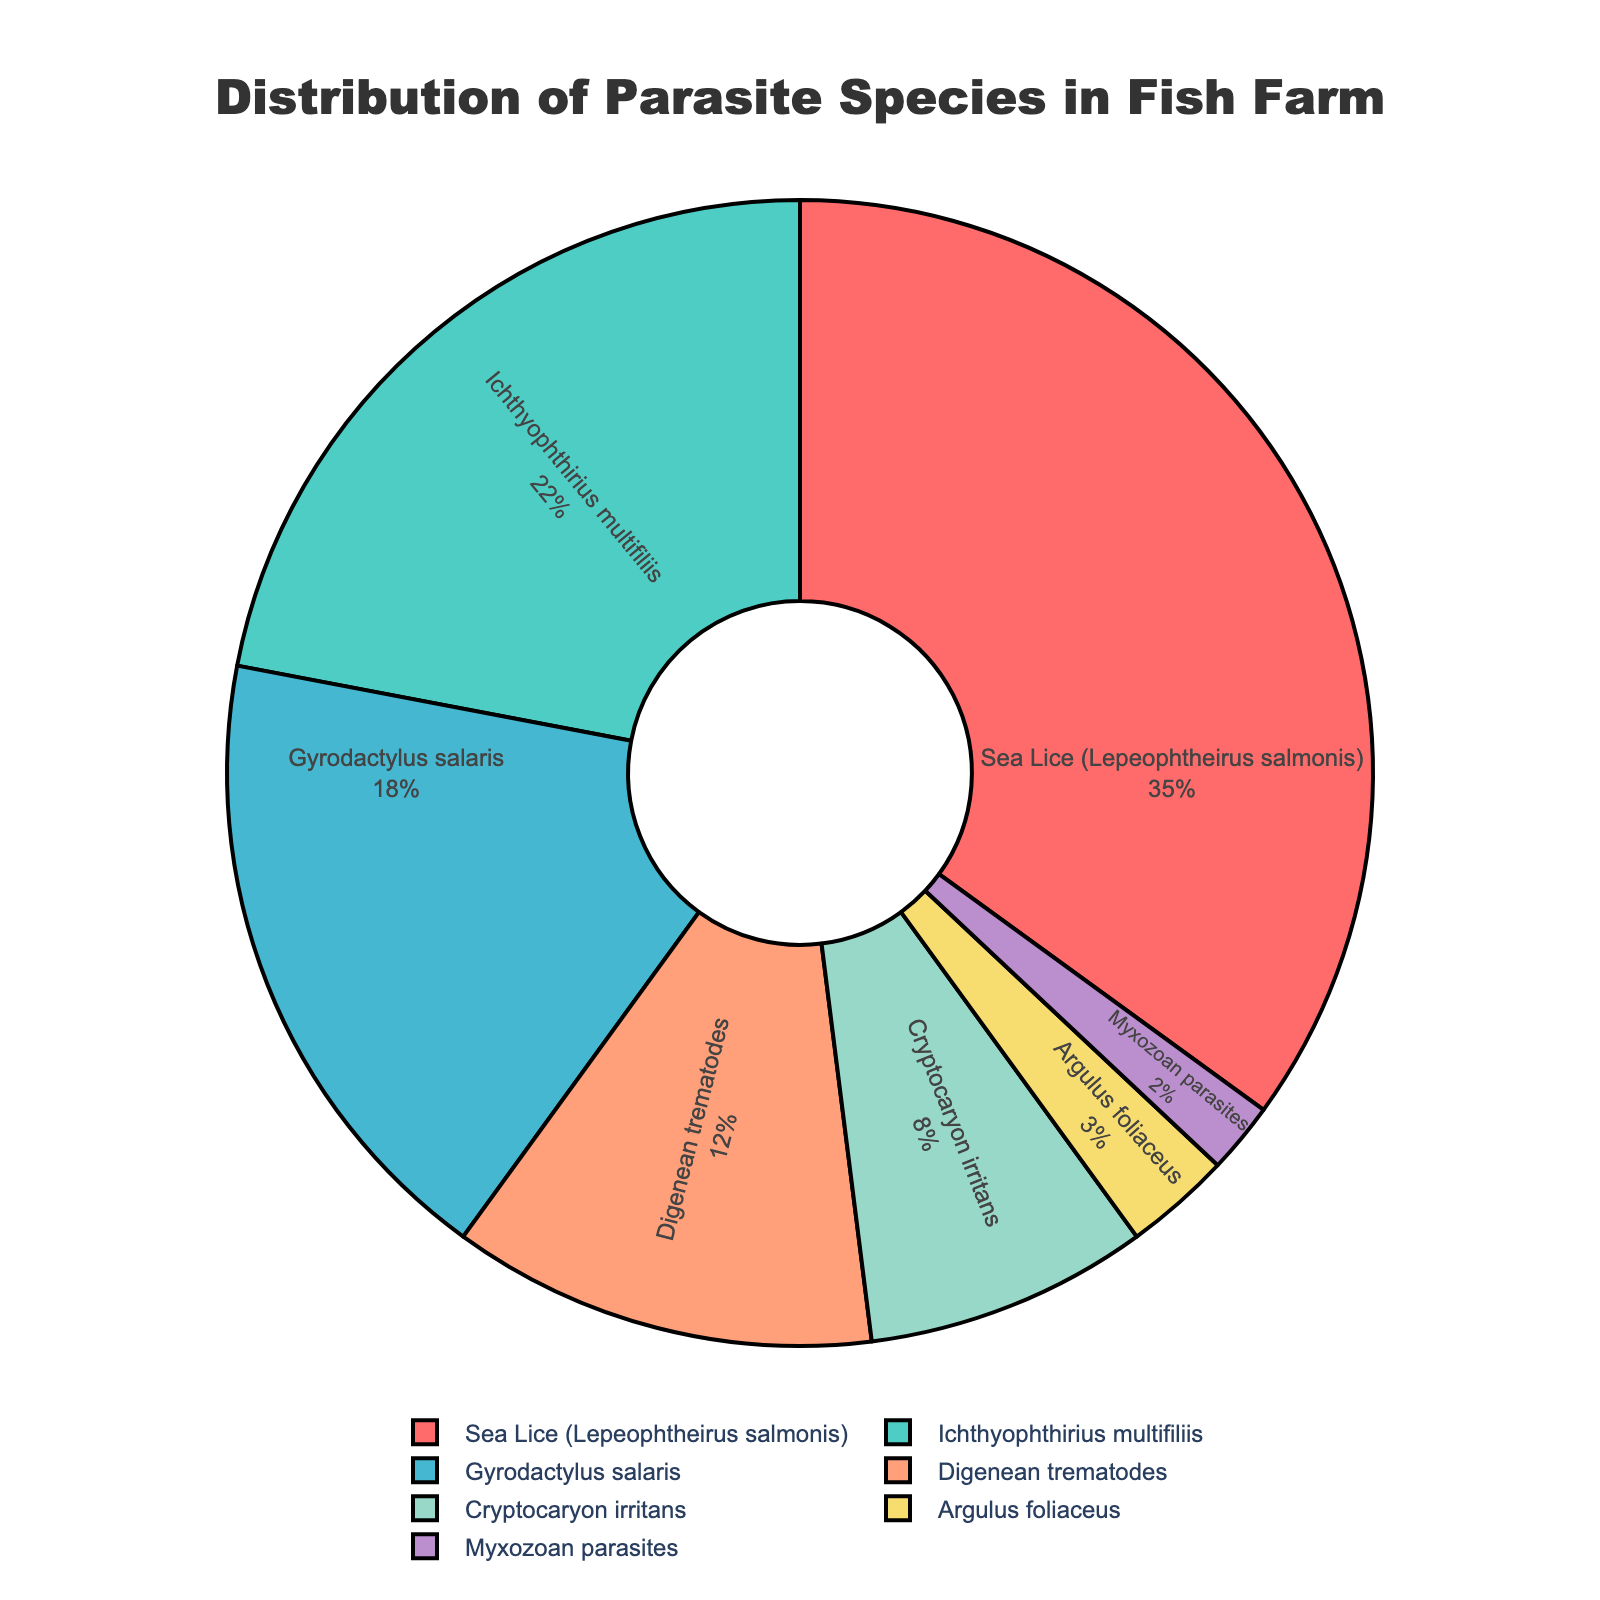What's the percentage of parasites caused by Sea Lice and Ichthyophthirius multifiliis combined? First, identify the percentage for Sea Lice, which is 35%, and for Ichthyophthirius multifiliis, which is 22%. Then, sum these percentages: 35% + 22% = 57%
Answer: 57% Which parasite type has the smallest share in the fish farm? Identify the parasite type with the smallest percentage; Myxozoan parasites have the smallest share at 2%
Answer: Myxozoan parasites What's the difference in percentage between Gyrodactylus salaris and Digenean trematodes? Find the percentages for Gyrodactylus salaris and Digenean trematodes, which are 18% and 12% respectively, then subtract: 18% - 12% = 6%
Answer: 6% Is the combined share of Argulus foliaceus and Cryptocaryon irritans greater than that of Gyrodactylus salaris? Calculate the sum for Argulus foliaceus (3%) and Cryptocaryon irritans (8%), which is 3% + 8% = 11%, and compare it to the 18% for Gyrodactylus salaris. Since 11% < 18%, the combined share is not greater.
Answer: No What percentage of the parasites are caused by types other than Sea Lice? Calculate the total percentage of all parasites except Sea Lice by summing up their percentages: 22% (Ichthyophthirius multifiliis) + 18% (Gyrodactylus salaris) + 12% (Digenean trematodes) + 8% (Cryptocaryon irritans) + 3% (Argulus foliaceus) + 2% (Myxozoan parasites) = 65%
Answer: 65% Which color represents the Cryptocaryon irritans on the pie chart? Identify the color associated with Cryptocaryon irritans; in the plots, it is represented by the color yellow.
Answer: Yellow Which parasite type has a share that is equal to or greater than 20%? Check each parasite type’s percentage and find the ones equal to or greater than 20%. Sea Lice (35%) and Ichthyophthirius multifiliis (22%) both meet this criterion.
Answer: Sea Lice, Ichthyophthirius multifiliis What is the average percentage of the lesser prevalent parasites (Cryptocaryon irritans, Argulus foliaceus, and Myxozoan parasites)? Sum the percentages of Cryptocaryon irritans (8%), Argulus foliaceus (3%), and Myxozoan parasites (2%) = 8% + 3% + 2% = 13%. Then, divide by the number of parasite types (3): 13% / 3 = approximately 4.33%.
Answer: 4.33% 